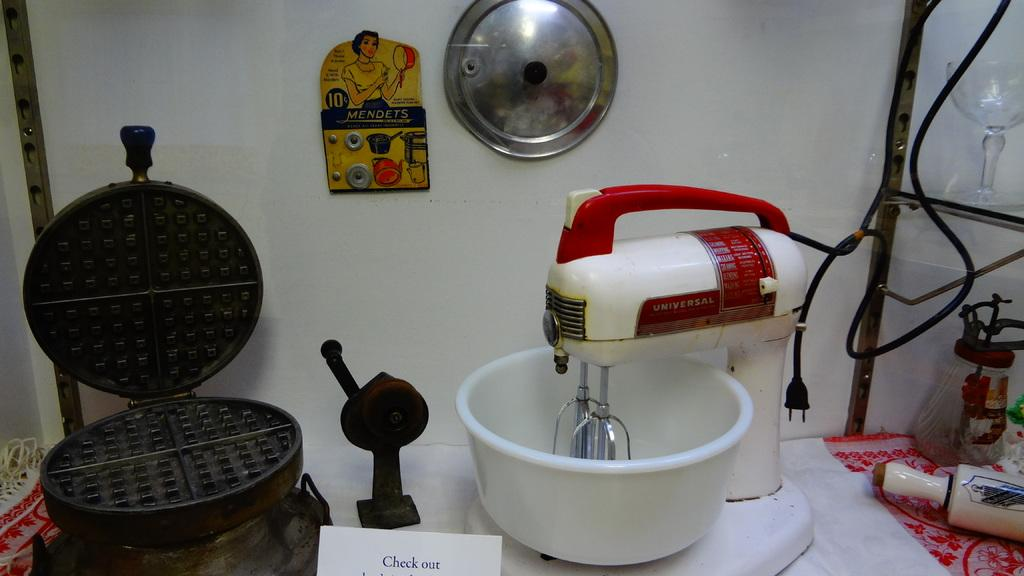<image>
Relay a brief, clear account of the picture shown. A number of cooking wares are on a table with a white piece of paper saying Check out in front of them. 